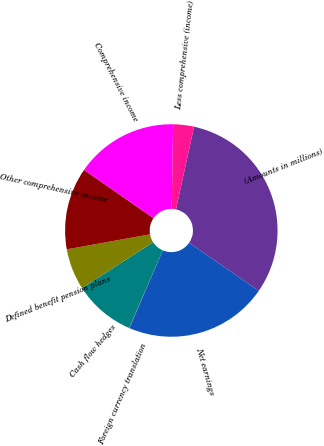Convert chart to OTSL. <chart><loc_0><loc_0><loc_500><loc_500><pie_chart><fcel>(Amounts in millions)<fcel>Net earnings<fcel>Foreign currency translation<fcel>Cash flow hedges<fcel>Defined benefit pension plans<fcel>Other comprehensive income<fcel>Comprehensive income<fcel>Less comprehensive (income)<nl><fcel>31.18%<fcel>21.84%<fcel>0.04%<fcel>9.39%<fcel>6.27%<fcel>12.5%<fcel>15.61%<fcel>3.16%<nl></chart> 